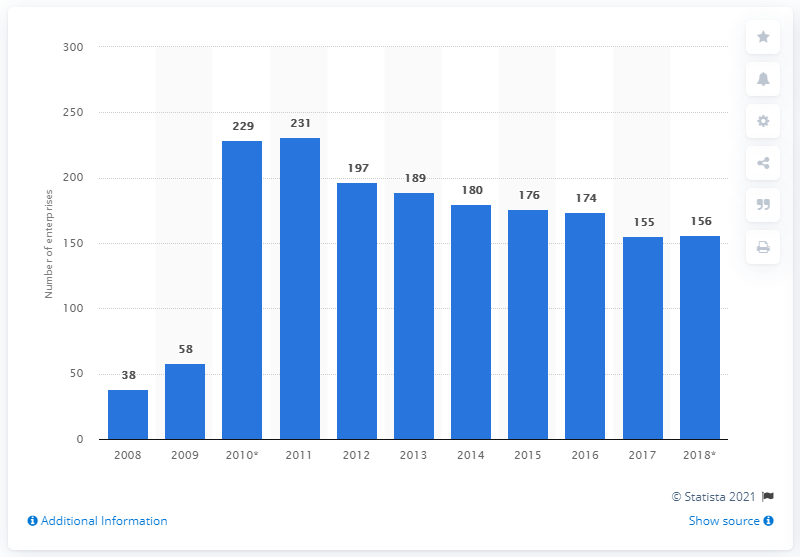List a handful of essential elements in this visual. In 2018, 156 enterprises were involved in the manufacture of dairy products in Slovakia. 